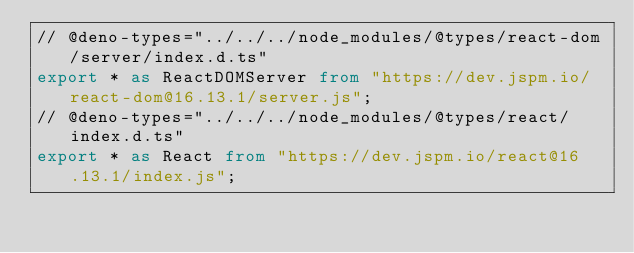Convert code to text. <code><loc_0><loc_0><loc_500><loc_500><_TypeScript_>// @deno-types="../../../node_modules/@types/react-dom/server/index.d.ts"
export * as ReactDOMServer from "https://dev.jspm.io/react-dom@16.13.1/server.js";
// @deno-types="../../../node_modules/@types/react/index.d.ts"
export * as React from "https://dev.jspm.io/react@16.13.1/index.js";
</code> 